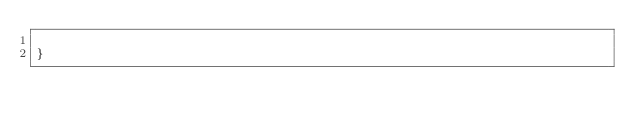<code> <loc_0><loc_0><loc_500><loc_500><_Scala_>
}
</code> 